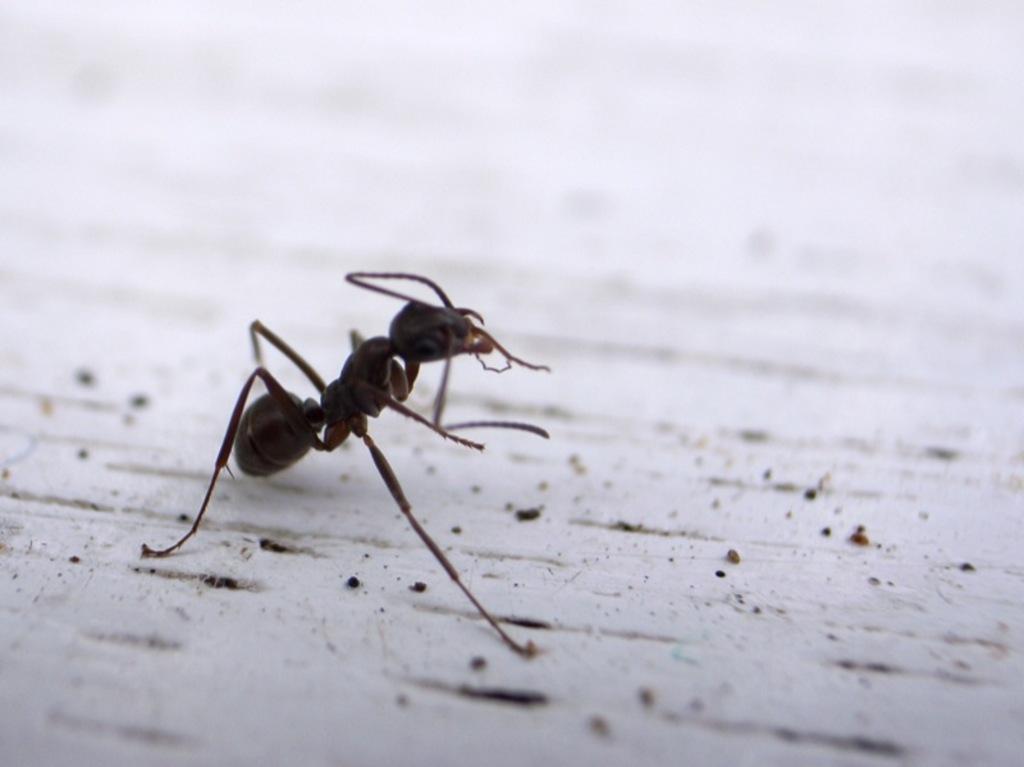Please provide a concise description of this image. In this image, we can see an ant. In the background, image is blurred. 